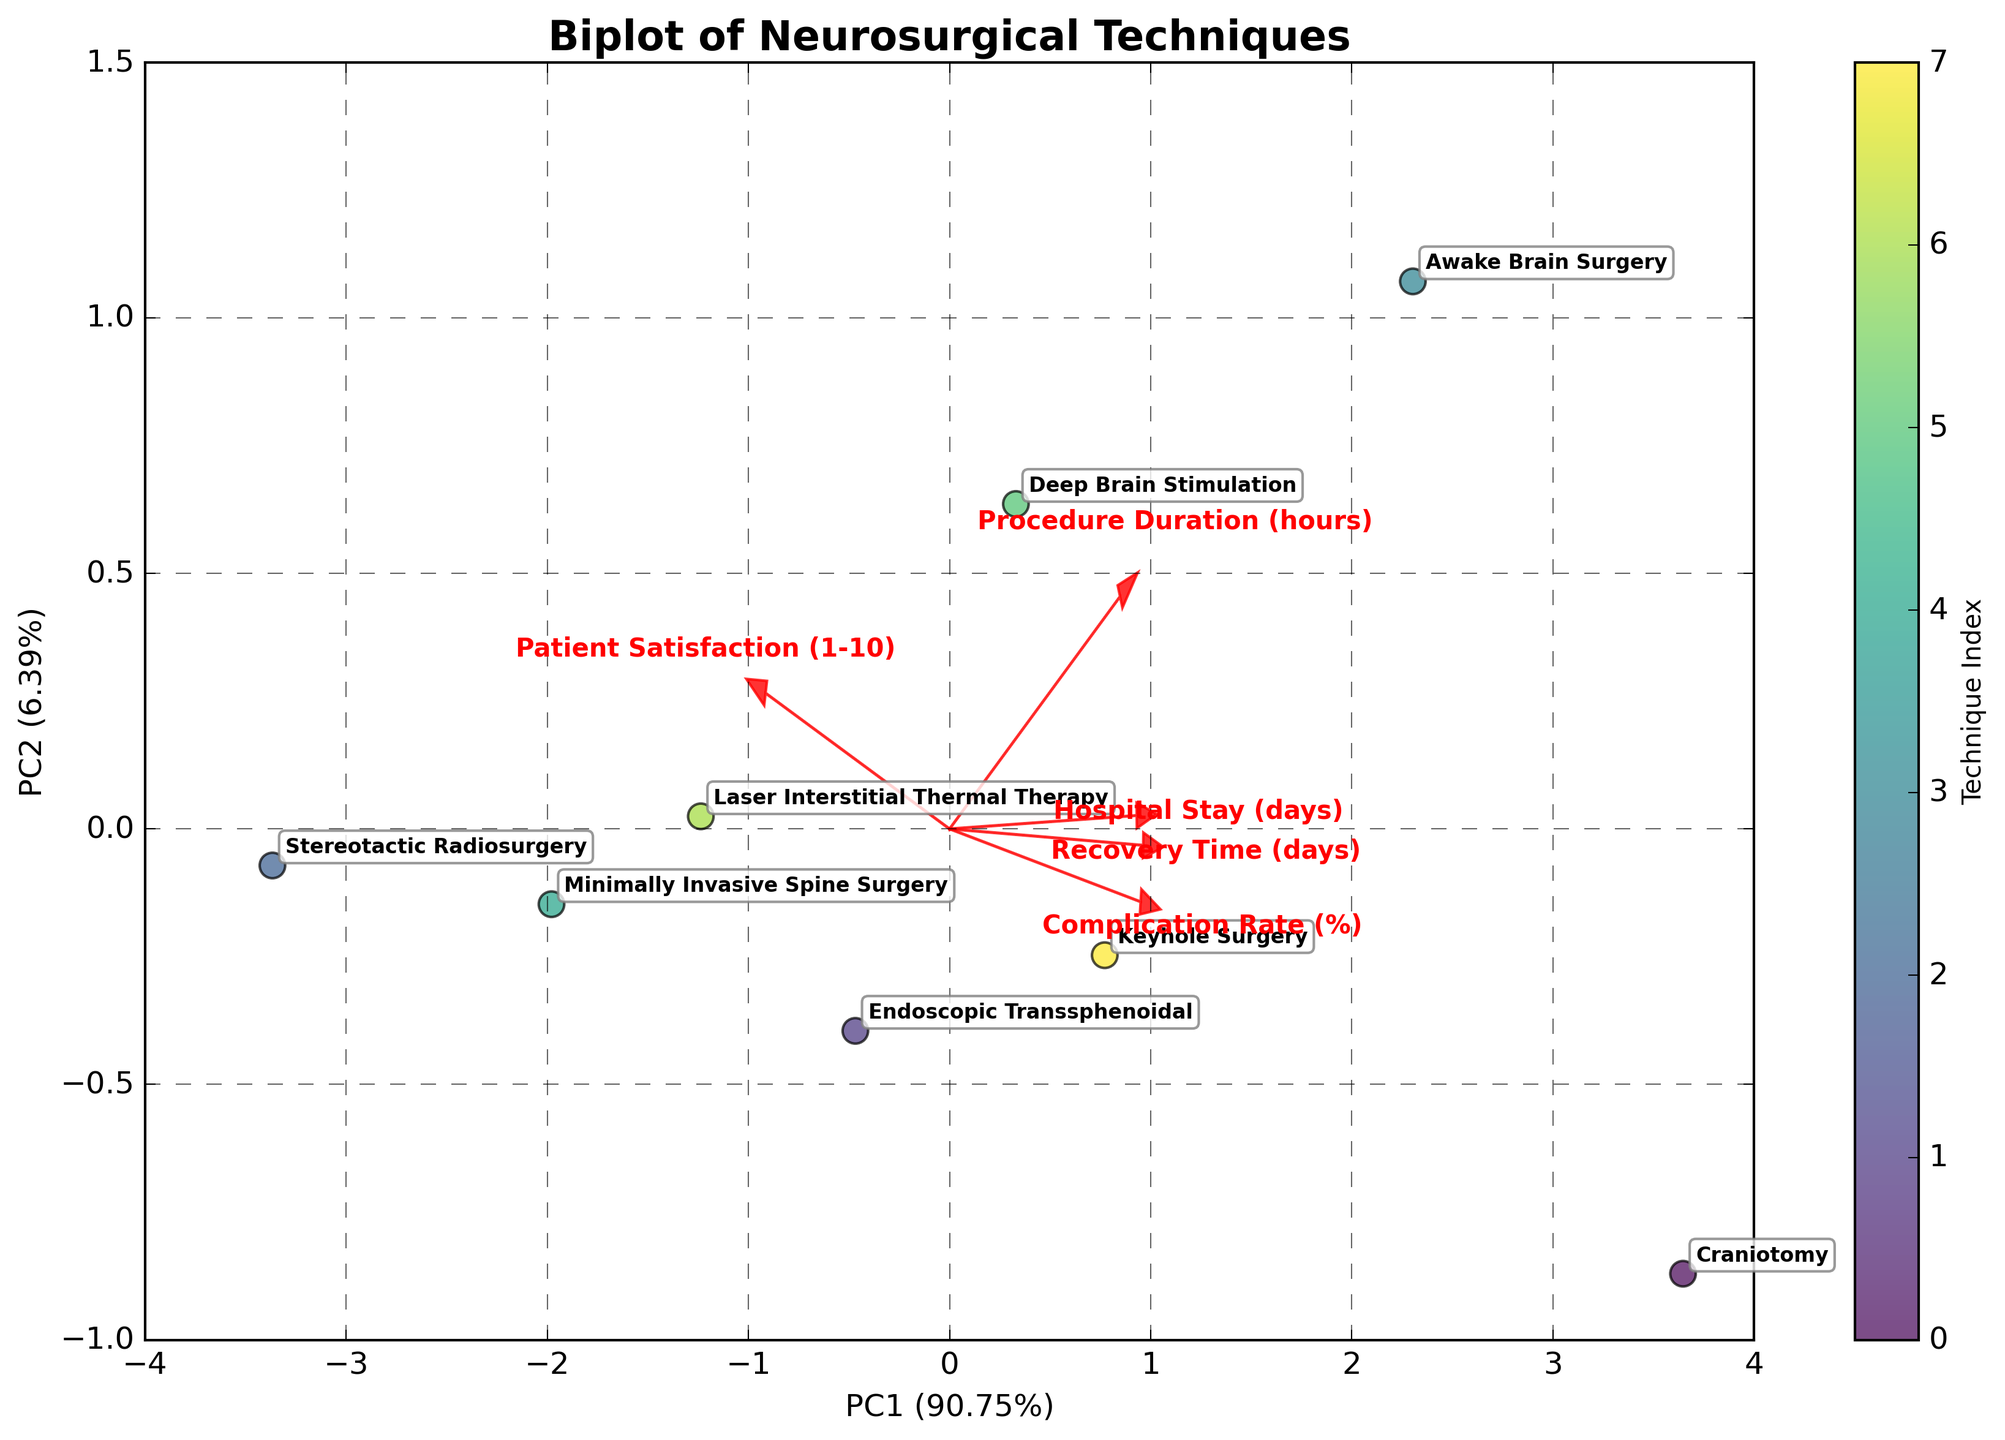How many neurosurgical techniques are represented in the biplot? The biplot has labels for each neurosurgical technique. By counting the unique labels, we can determine the number of techniques.
Answer: 8 Which neurosurgical technique has the shortest recovery time? By looking for the data point (technique) closest to the vector representing "Recovery Time (days)" moving towards the left, we identify it.
Answer: Stereotactic Radiosurgery How does Minimally Invasive Spine Surgery compare to Awake Brain Surgery in terms of patient satisfaction? We look at the positions of these two techniques in relation to the "Patient Satisfaction (1-10)" vector. Minimally Invasive Spine Surgery is closer to the vector's positive direction than Awake Brain Surgery.
Answer: Higher Between Craniotomy and Keyhole Surgery, which technique has a longer hospital stay? By comparing the positions of Craniotomy and Keyhole Surgery relative to the "Hospital Stay (days)" vector, we note the technique further along the vector.
Answer: Craniotomy Which feature most strongly influences the separation on PC1? By examining the loading vectors, the vector with the longest arrow along the PC1 axis indicates the most significant feature.
Answer: Recovery Time (days) What is the relationship between procedure duration and complication rate for Deep Brain Stimulation? Comparing the position of Deep Brain Stimulation relative to the vectors for "Procedure Duration (hours)" and "Complication Rate (%)", both vectors point reasonably towards this technique.
Answer: High for both Which technique balances high patient satisfaction and shorter hospital stays? Looking for a technique near the positive ends of both "Patient Satisfaction (1-10)" and "Hospital Stay (days)" vectors, Stereotactic Radiosurgery appears balanced.
Answer: Stereotactic Radiosurgery Do longer procedure durations correlate with higher or lower complication rates? Observing the directions of the vectors for "Procedure Duration (hours)" and "Complication Rate (%)", they are oriented similarly. This indicates a positive correlation.
Answer: Higher Which feature contributes least to the separation on PC2? Analyzing the lengths and orientations of the arrows, the feature with the shortest vector along PC2 axis has the least contribution.
Answer: Complication Rate (%) 